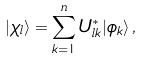Convert formula to latex. <formula><loc_0><loc_0><loc_500><loc_500>| \chi _ { l } \rangle = \sum _ { k = 1 } ^ { n } U _ { l k } ^ { * } | \phi _ { k } \rangle \, ,</formula> 